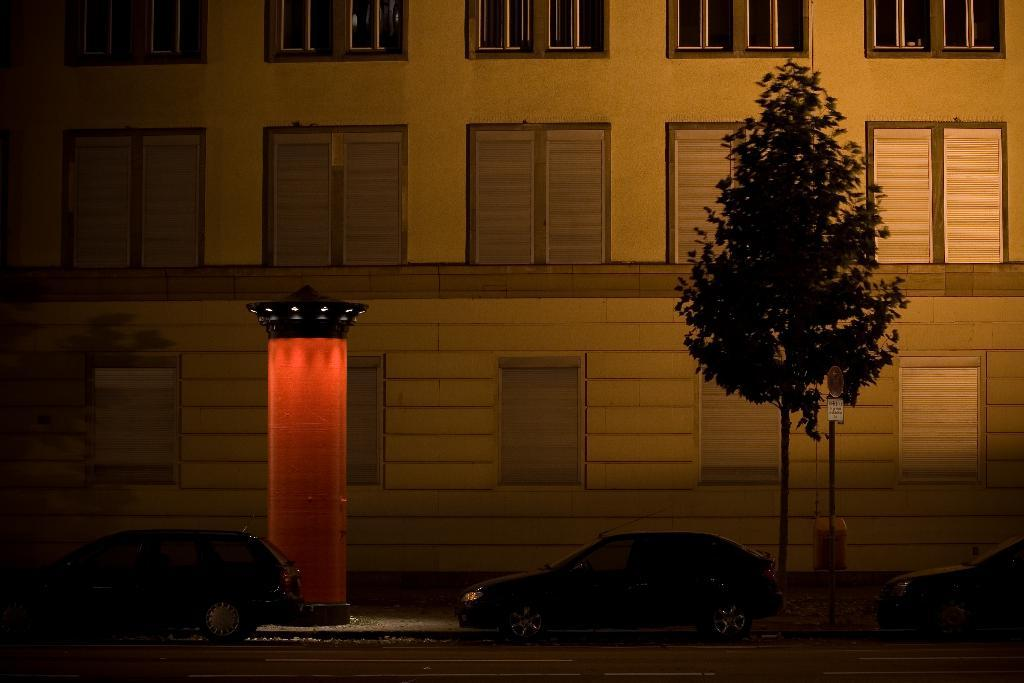What can be seen on the road in the image? There are vehicles on the road in the image. What type of plant is present in the image? There is a tree in the image. What is attached to the pole in the image? There is a pole with boards in the image. Can you describe the object in the image? There is an object in the image, but its specific nature is not clear from the provided facts. What is visible in the background of the image? There is a building in the background of the image. What type of mask is being worn by the tree in the image? There is no mask present in the image, and the tree is not wearing anything. What historical event is depicted in the image? There is no historical event depicted in the image; it features vehicles on the road, a tree, a pole with boards, an object, and a building in the background. 